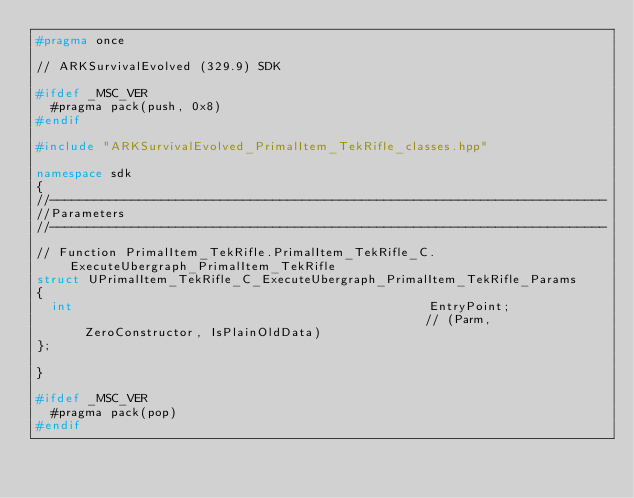Convert code to text. <code><loc_0><loc_0><loc_500><loc_500><_C++_>#pragma once

// ARKSurvivalEvolved (329.9) SDK

#ifdef _MSC_VER
	#pragma pack(push, 0x8)
#endif

#include "ARKSurvivalEvolved_PrimalItem_TekRifle_classes.hpp"

namespace sdk
{
//---------------------------------------------------------------------------
//Parameters
//---------------------------------------------------------------------------

// Function PrimalItem_TekRifle.PrimalItem_TekRifle_C.ExecuteUbergraph_PrimalItem_TekRifle
struct UPrimalItem_TekRifle_C_ExecuteUbergraph_PrimalItem_TekRifle_Params
{
	int                                                EntryPoint;                                               // (Parm, ZeroConstructor, IsPlainOldData)
};

}

#ifdef _MSC_VER
	#pragma pack(pop)
#endif
</code> 